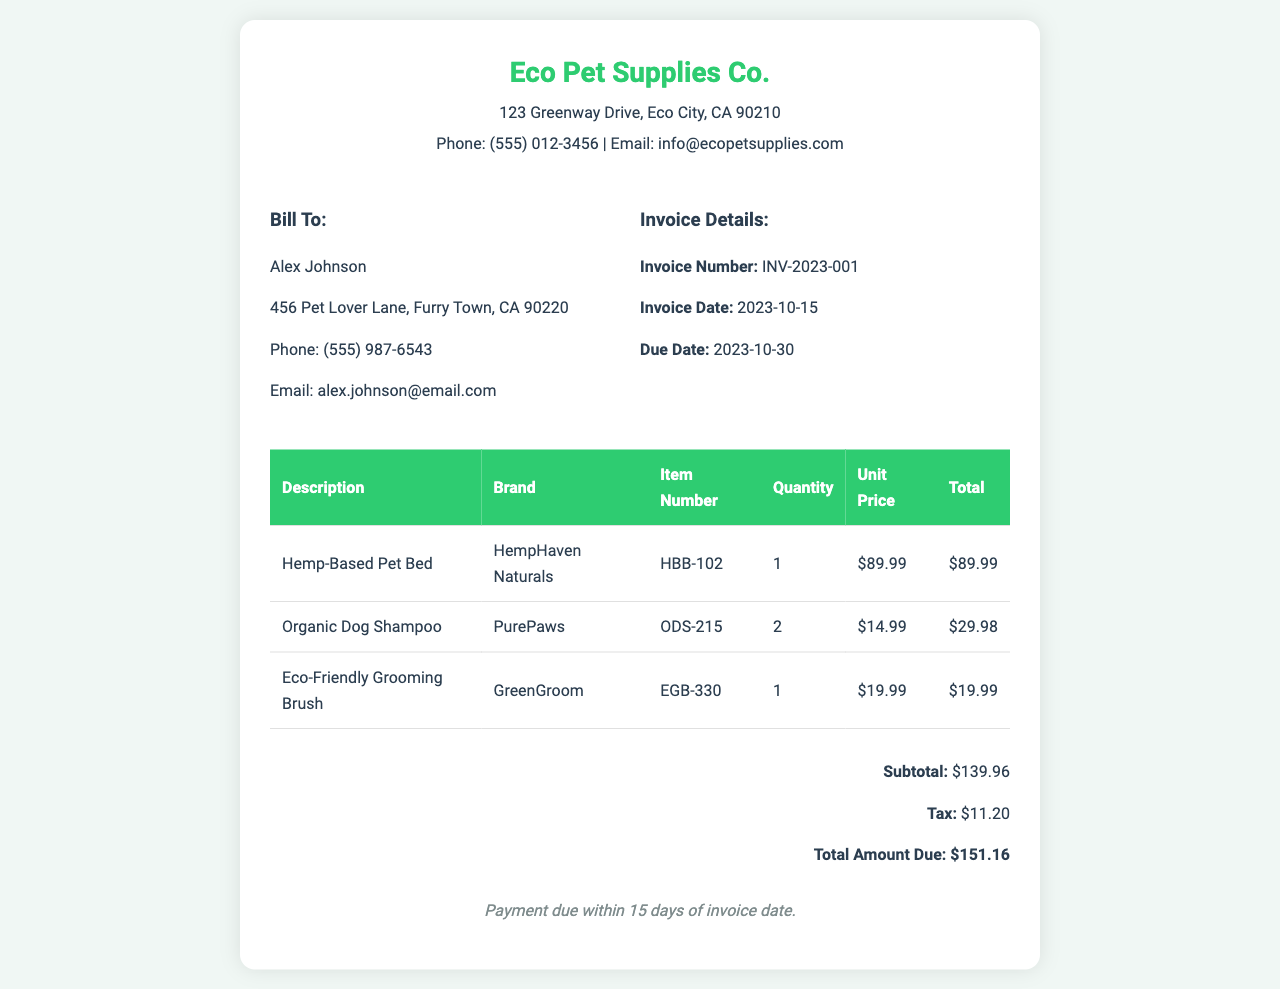What is the invoice number? The invoice number is specifically listed in the invoice details section, labeled as "Invoice Number."
Answer: INV-2023-001 What is the due date for payment? The due date is mentioned in the invoice details under "Due Date."
Answer: 2023-10-30 Who is the billed recipient? The bill to section clearly states the recipient's name and details.
Answer: Alex Johnson What is the subtotal amount? The subtotal is calculated before tax and is clearly listed in the total section.
Answer: $139.96 How many Organic Dog Shampoo items were purchased? The quantity of Organic Dog Shampoo is specified in the product listing table.
Answer: 2 What is the total amount due? The total amount due is presented at the end of the invoice.
Answer: $151.16 Which company manufactured the Eco-Friendly Grooming Brush? The brand of Eco-Friendly Grooming Brush is stated in the product table.
Answer: GreenGroom What is the tax amount applied to the invoice? The tax amount can be found in the total section below the subtotal.
Answer: $11.20 When was the invoice generated? The date of the invoice is explicitly listed in the invoice details section.
Answer: 2023-10-15 